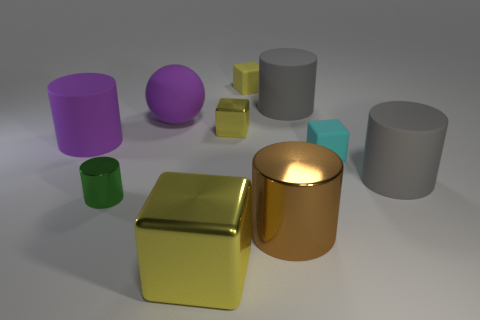Are there fewer tiny cyan objects that are in front of the green cylinder than big cylinders?
Offer a very short reply. Yes. How many other objects are there of the same material as the cyan cube?
Ensure brevity in your answer.  5. Does the purple matte sphere have the same size as the green thing?
Give a very brief answer. No. How many things are either tiny green cylinders in front of the big purple rubber ball or small green metal cylinders?
Ensure brevity in your answer.  1. There is a tiny thing that is behind the small yellow block that is on the left side of the yellow matte object; what is its material?
Your response must be concise. Rubber. Is there another shiny thing that has the same shape as the big brown thing?
Provide a short and direct response. Yes. Is the size of the purple rubber cylinder the same as the purple object that is on the right side of the green object?
Your answer should be very brief. Yes. How many things are yellow things in front of the big purple cylinder or matte things to the left of the cyan object?
Make the answer very short. 5. Is the number of cylinders behind the cyan rubber cube greater than the number of big brown shiny cubes?
Your answer should be very brief. Yes. What number of yellow objects are the same size as the brown metal object?
Your answer should be very brief. 1. 